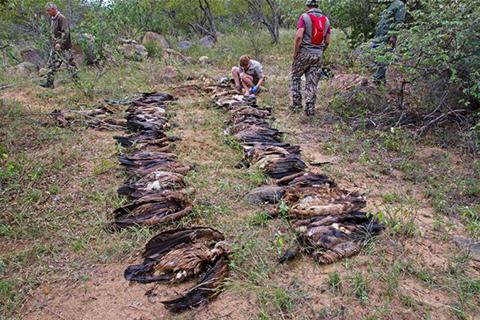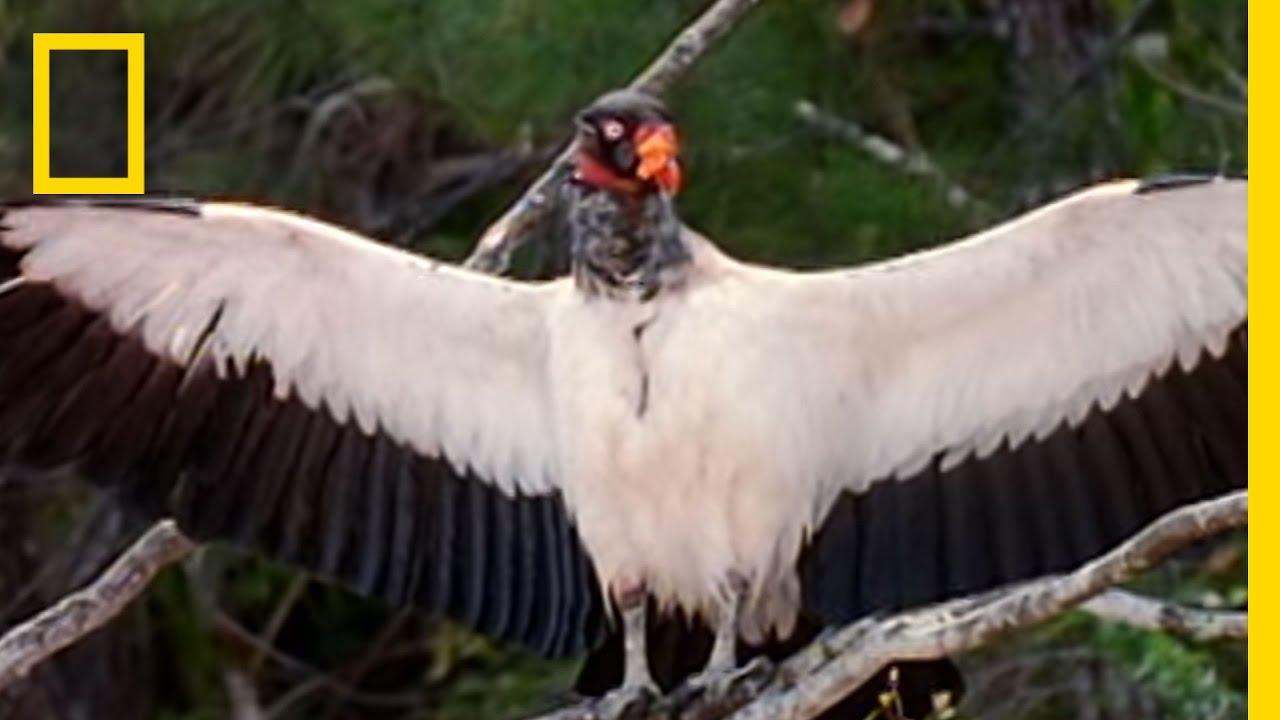The first image is the image on the left, the second image is the image on the right. Evaluate the accuracy of this statement regarding the images: "rows of dead vultures are in the grass with at least one human in the backgroud". Is it true? Answer yes or no. Yes. The first image is the image on the left, the second image is the image on the right. Analyze the images presented: Is the assertion "there are humans in the pics" valid? Answer yes or no. Yes. 